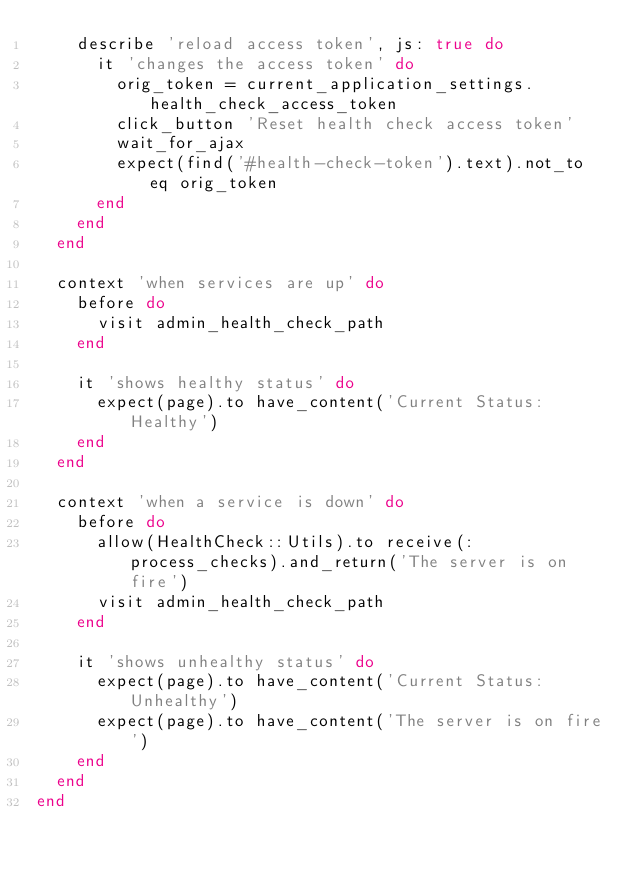Convert code to text. <code><loc_0><loc_0><loc_500><loc_500><_Ruby_>    describe 'reload access token', js: true do
      it 'changes the access token' do
        orig_token = current_application_settings.health_check_access_token
        click_button 'Reset health check access token'
        wait_for_ajax
        expect(find('#health-check-token').text).not_to eq orig_token
      end
    end
  end

  context 'when services are up' do
    before do
      visit admin_health_check_path
    end

    it 'shows healthy status' do
      expect(page).to have_content('Current Status: Healthy')
    end
  end

  context 'when a service is down' do
    before do
      allow(HealthCheck::Utils).to receive(:process_checks).and_return('The server is on fire')
      visit admin_health_check_path
    end

    it 'shows unhealthy status' do
      expect(page).to have_content('Current Status: Unhealthy')
      expect(page).to have_content('The server is on fire')
    end
  end
end
</code> 